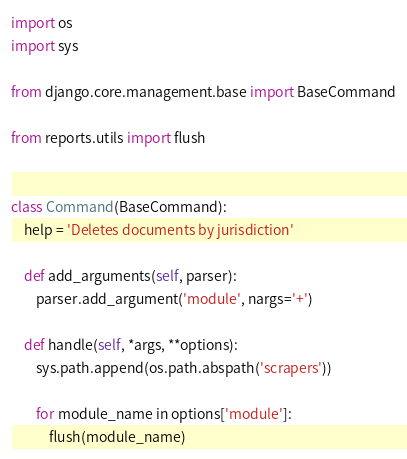Convert code to text. <code><loc_0><loc_0><loc_500><loc_500><_Python_>import os
import sys

from django.core.management.base import BaseCommand

from reports.utils import flush


class Command(BaseCommand):
    help = 'Deletes documents by jurisdiction'

    def add_arguments(self, parser):
        parser.add_argument('module', nargs='+')

    def handle(self, *args, **options):
        sys.path.append(os.path.abspath('scrapers'))

        for module_name in options['module']:
            flush(module_name)
</code> 